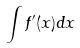<formula> <loc_0><loc_0><loc_500><loc_500>\int f ^ { \prime } ( x ) d x</formula> 